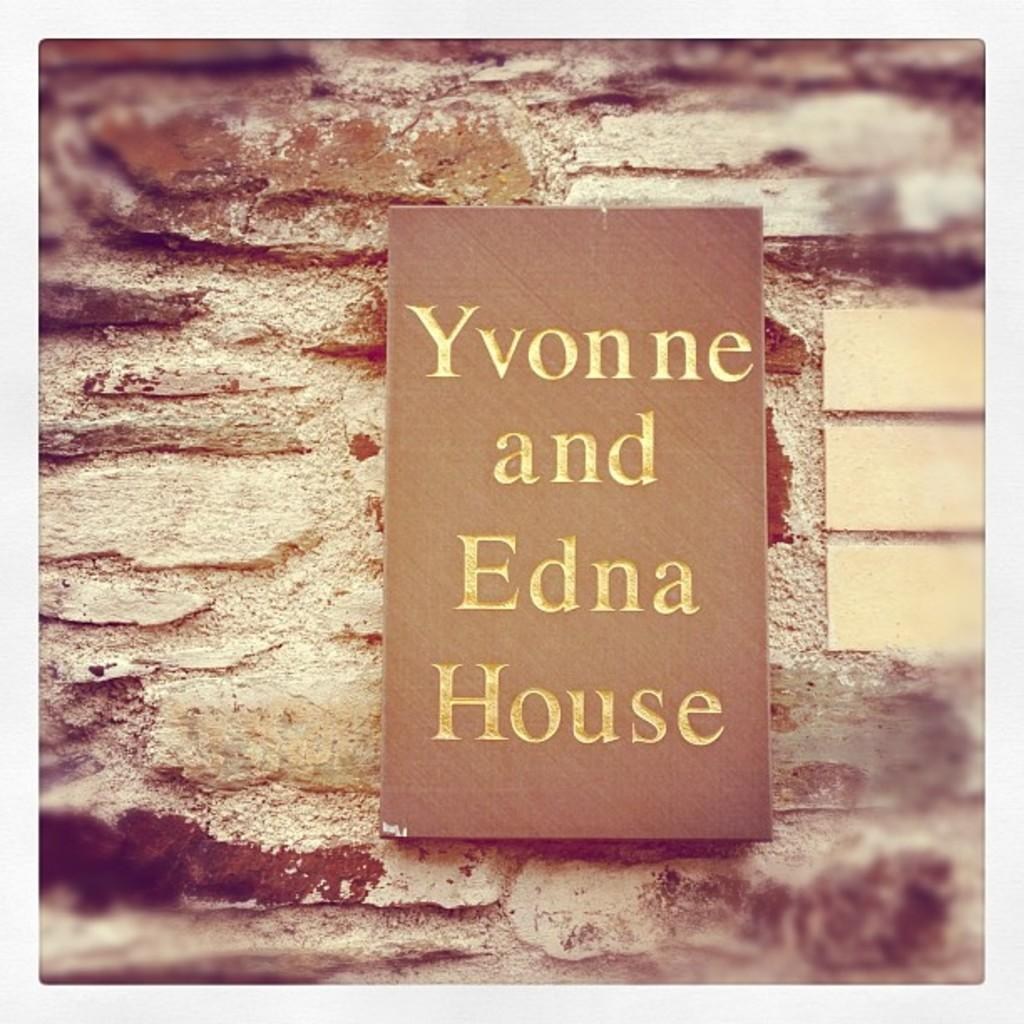<image>
Share a concise interpretation of the image provided. Sign saying Yvonne and Edna House on a wall. 